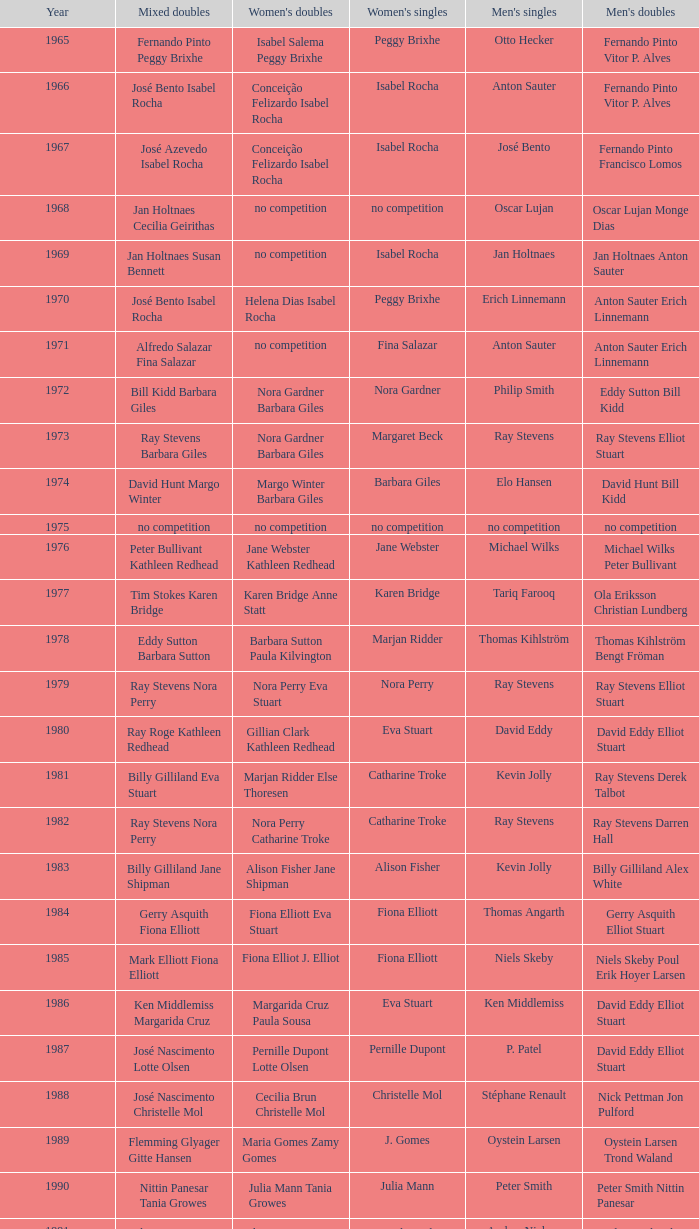Parse the full table. {'header': ['Year', 'Mixed doubles', "Women's doubles", "Women's singles", "Men's singles", "Men's doubles"], 'rows': [['1965', 'Fernando Pinto Peggy Brixhe', 'Isabel Salema Peggy Brixhe', 'Peggy Brixhe', 'Otto Hecker', 'Fernando Pinto Vitor P. Alves'], ['1966', 'José Bento Isabel Rocha', 'Conceição Felizardo Isabel Rocha', 'Isabel Rocha', 'Anton Sauter', 'Fernando Pinto Vitor P. Alves'], ['1967', 'José Azevedo Isabel Rocha', 'Conceição Felizardo Isabel Rocha', 'Isabel Rocha', 'José Bento', 'Fernando Pinto Francisco Lomos'], ['1968', 'Jan Holtnaes Cecilia Geirithas', 'no competition', 'no competition', 'Oscar Lujan', 'Oscar Lujan Monge Dias'], ['1969', 'Jan Holtnaes Susan Bennett', 'no competition', 'Isabel Rocha', 'Jan Holtnaes', 'Jan Holtnaes Anton Sauter'], ['1970', 'José Bento Isabel Rocha', 'Helena Dias Isabel Rocha', 'Peggy Brixhe', 'Erich Linnemann', 'Anton Sauter Erich Linnemann'], ['1971', 'Alfredo Salazar Fina Salazar', 'no competition', 'Fina Salazar', 'Anton Sauter', 'Anton Sauter Erich Linnemann'], ['1972', 'Bill Kidd Barbara Giles', 'Nora Gardner Barbara Giles', 'Nora Gardner', 'Philip Smith', 'Eddy Sutton Bill Kidd'], ['1973', 'Ray Stevens Barbara Giles', 'Nora Gardner Barbara Giles', 'Margaret Beck', 'Ray Stevens', 'Ray Stevens Elliot Stuart'], ['1974', 'David Hunt Margo Winter', 'Margo Winter Barbara Giles', 'Barbara Giles', 'Elo Hansen', 'David Hunt Bill Kidd'], ['1975', 'no competition', 'no competition', 'no competition', 'no competition', 'no competition'], ['1976', 'Peter Bullivant Kathleen Redhead', 'Jane Webster Kathleen Redhead', 'Jane Webster', 'Michael Wilks', 'Michael Wilks Peter Bullivant'], ['1977', 'Tim Stokes Karen Bridge', 'Karen Bridge Anne Statt', 'Karen Bridge', 'Tariq Farooq', 'Ola Eriksson Christian Lundberg'], ['1978', 'Eddy Sutton Barbara Sutton', 'Barbara Sutton Paula Kilvington', 'Marjan Ridder', 'Thomas Kihlström', 'Thomas Kihlström Bengt Fröman'], ['1979', 'Ray Stevens Nora Perry', 'Nora Perry Eva Stuart', 'Nora Perry', 'Ray Stevens', 'Ray Stevens Elliot Stuart'], ['1980', 'Ray Roge Kathleen Redhead', 'Gillian Clark Kathleen Redhead', 'Eva Stuart', 'David Eddy', 'David Eddy Elliot Stuart'], ['1981', 'Billy Gilliland Eva Stuart', 'Marjan Ridder Else Thoresen', 'Catharine Troke', 'Kevin Jolly', 'Ray Stevens Derek Talbot'], ['1982', 'Ray Stevens Nora Perry', 'Nora Perry Catharine Troke', 'Catharine Troke', 'Ray Stevens', 'Ray Stevens Darren Hall'], ['1983', 'Billy Gilliland Jane Shipman', 'Alison Fisher Jane Shipman', 'Alison Fisher', 'Kevin Jolly', 'Billy Gilliland Alex White'], ['1984', 'Gerry Asquith Fiona Elliott', 'Fiona Elliott Eva Stuart', 'Fiona Elliott', 'Thomas Angarth', 'Gerry Asquith Elliot Stuart'], ['1985', 'Mark Elliott Fiona Elliott', 'Fiona Elliot J. Elliot', 'Fiona Elliott', 'Niels Skeby', 'Niels Skeby Poul Erik Hoyer Larsen'], ['1986', 'Ken Middlemiss Margarida Cruz', 'Margarida Cruz Paula Sousa', 'Eva Stuart', 'Ken Middlemiss', 'David Eddy Elliot Stuart'], ['1987', 'José Nascimento Lotte Olsen', 'Pernille Dupont Lotte Olsen', 'Pernille Dupont', 'P. Patel', 'David Eddy Elliot Stuart'], ['1988', 'José Nascimento Christelle Mol', 'Cecilia Brun Christelle Mol', 'Christelle Mol', 'Stéphane Renault', 'Nick Pettman Jon Pulford'], ['1989', 'Flemming Glyager Gitte Hansen', 'Maria Gomes Zamy Gomes', 'J. Gomes', 'Oystein Larsen', 'Oystein Larsen Trond Waland'], ['1990', 'Nittin Panesar Tania Growes', 'Julia Mann Tania Growes', 'Julia Mann', 'Peter Smith', 'Peter Smith Nittin Panesar'], ['1991', 'Chris Hunt Tracy Dineen', 'Elena Denisova Marina Yakusheva', 'Astrid van der Knaap', 'Anders Nielsen', 'Andy Goode Glen Milton'], ['1992', 'Andy Goode Joanne Wright', 'Joanne Wright Joanne Davies', 'Elena Rybkina', 'Andrey Antropov', 'Andy Goode Chris Hunt'], ['1993', 'Nikolaj Zuev Marina Yakusheva', 'Marina Andrievskaja Irina Yakusheva', 'Marina Andrievskaia', 'Andrey Antropov', 'Chan Kin Ngai Wong Wai Lap'], ['1994', 'Martin Lundgaard Hansen Rikke Olsen', 'Rikke Olsen Helene Kirkegaard', 'Irina Yakusheva', 'Martin Lundgaard Hansen', 'Thomas Damgaard Jan Jörgensen'], ['1995', 'Peder Nissen Mette Hansen', 'Majken Vange Mette Hansen', 'Anne Sondergaard', 'Martin Lundgaard Hansen', 'Hendrik Sörensen Martin Lundgaard Hansen'], ['1996', 'Nathan Robertson Gail Emms', 'Emma Chaffin Tracy Hallam', 'Karolina Ericsson', 'Rikard Magnusson', 'Ian Pearson James Anderson'], ['1997', 'Russel Hogg Alexis Blanchflower', 'Karen Peatfield Tracy Hallam', 'Ann Gibson', 'Peter Janum', 'Fernando Silva Hugo Rodrigues'], ['1998', 'Ian Sydie Denyse Julien', 'Tracy Dineen Sarah Hardaker', 'Tanya Woodward', 'Niels Christian Kaldau', 'James Anderson Ian Pearson'], ['1999', 'Björn Siegemund Karen Stechmann', 'Sara Sankey Ella Miles', 'Ella Karachkova', 'Peter Janum', 'Manuel Dubrulle Vicent Laigle'], ['2000', 'Mathias Boe Karina Sørensen', 'Lene Mork Britta Andersen', 'Elena Nozdran', 'Rikard Magnusson', 'Janek Roos Joachim Fischer Nielsen'], ['2001', 'Björn Siegemund Nicol Pitro', 'Ella Miles Sarah Sankey', 'Pi Hongyan', 'Oliver Pongratz', 'Michael Keck Joachim Tesche'], ['2002', 'Frederik Bergström Jenny Karlsson', 'Lene Mork Christiansen Helle Nielsen', 'Julia Mann', 'Niels Christian Kaldau', 'Michael Logosz Robert Mateusiak'], ['2003', 'Fredrik Bergström Johanna Persson', 'Julie Houmann Helle Nielsen', 'Pi Hongyan', 'Niels Christian Kaldau', 'Jim Laugesen Michael Søgaard'], ['2004', 'Simon Archer Donna Kellogg', 'Nadieżda Kostiuczyk Kamila Augustyn', 'Tracey Hallam', 'Stanislav Pukhov', 'Simon Archer Robert Blair'], ['2005', 'Simon Archer Donna Kellogg', 'Sandra Marinello Katrin Piotrowski', 'Yuan Wemyss', 'Arif Rasidi', 'Anthony Clark Simon Archer'], ['2006', 'Rasmus M. Andersen Mie Schjott-Kristensen', 'Liza Parker Jenny Day', 'Yuan Wemyss', 'Michael Christensen', 'Anders Kristiansen Simon Mollyhus'], ['2007', 'Rasmus Bonde Christinna Pedersen', 'Jenny Wallwork Suzanne Rayappan', 'Judith Meulendijks', 'Peter Mikkelsen', 'Mikkel Delbo Larsen Jacob Chemnitz'], ['2008', 'Zhang Yi Cai Jiani', 'Cai Jiani Zhang Xi', 'Kaori Imabeppu', 'Anand Pawar', 'Ruud Bosch Koen Ridder'], ['2009', 'Lukasz Moren Natalia Pocztowiak', 'Emelie Lennartsson Emma Wengberg', 'Jill Pittard', 'Magnus Sahlberg', 'Ruben Gordown Stenny Kusuma'], ['2010', 'Zvonimir Durkinjak Stasa Poznanovic', 'Lauren Smith Alexandra Langley', 'Telma Santos', 'Kenn Lim', 'Martin Kragh Anders Skaarup Rasmussen'], ['2011', 'Robin Middleton Alexandra Langley', 'Lauren Smith Alexandra Langley', 'Sashina Vignes Waran', 'Sven-Eric Kastens', 'Niclas Nohr Mads Pedersen'], ['2012', 'Marcus Ellis Gabrielle White', 'Gabrielle White Alexandra Langley', 'Beatriz Corrales', 'Dieter Domke', 'Zvonimir Durkinjak Nikolaj Overgaard'], ['2013', 'Jones Rafli Jansen Keshya Nurvita Hanadia', 'Lena Grebak Maria Helsbol', 'Ella Diehl', 'Ramdan Misbun', 'Anders Skaarup Rasmussen Kim Astrup Sorensen']]} Which women's doubles happened after 1987 and a women's single of astrid van der knaap? Elena Denisova Marina Yakusheva. 